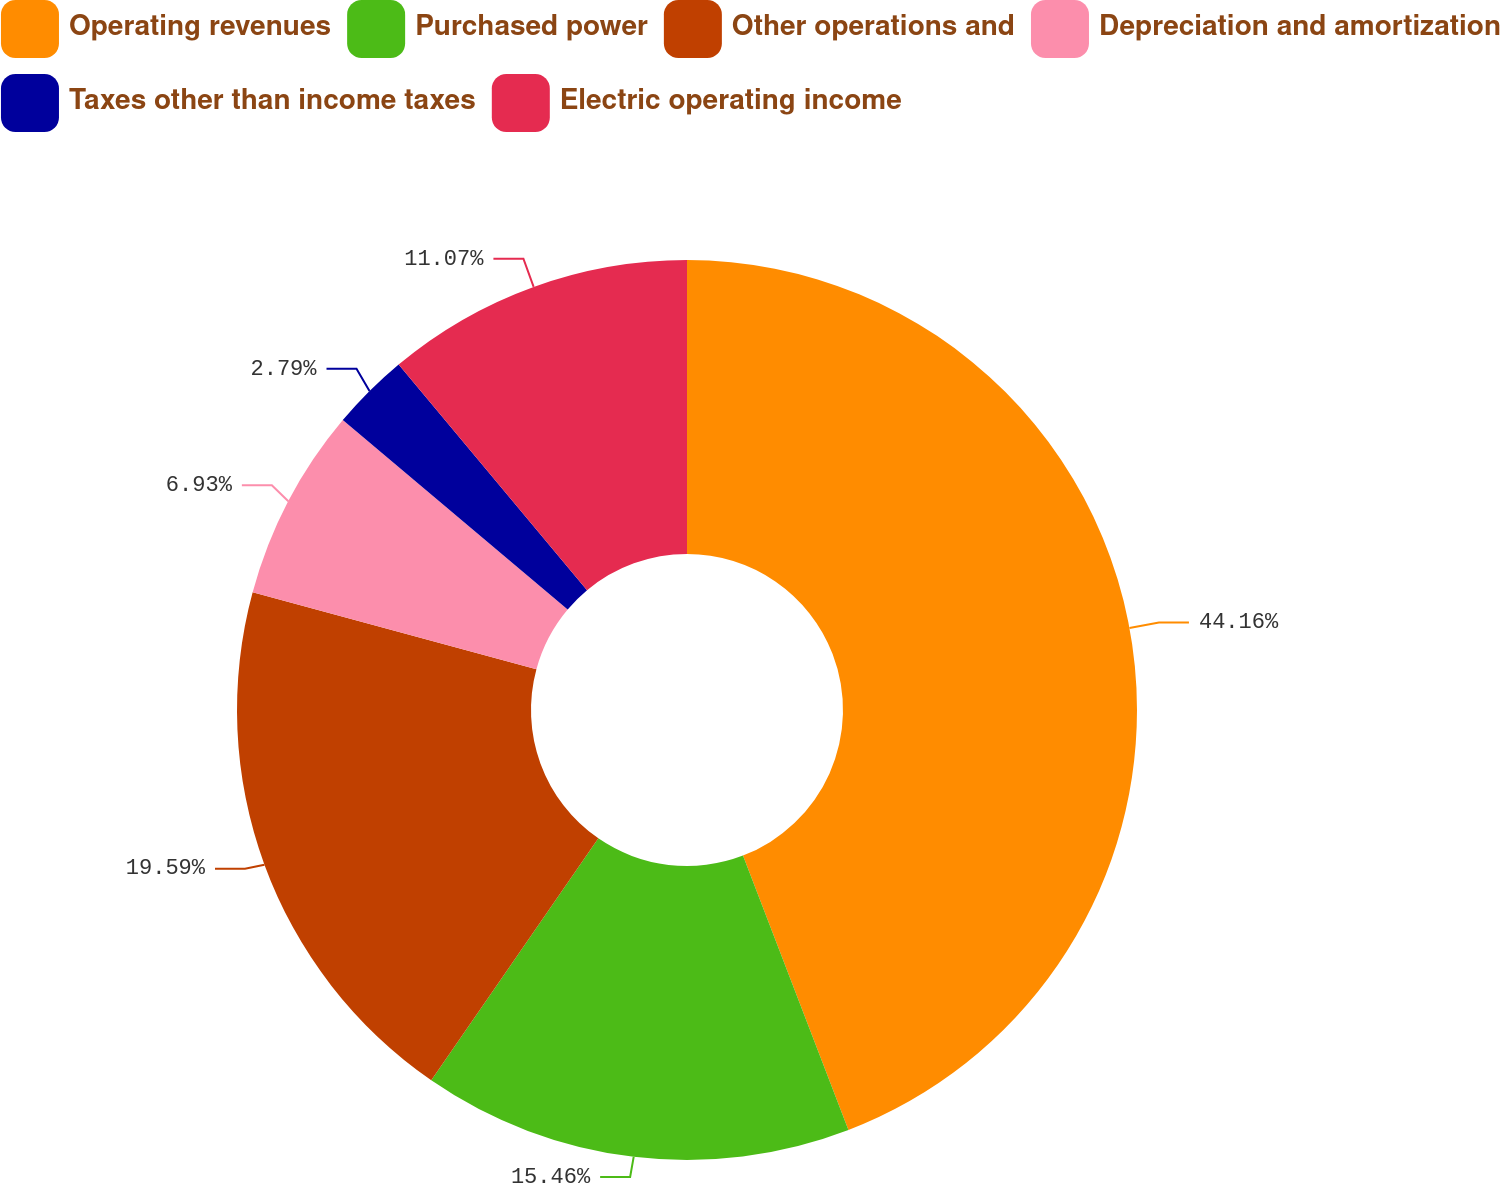Convert chart to OTSL. <chart><loc_0><loc_0><loc_500><loc_500><pie_chart><fcel>Operating revenues<fcel>Purchased power<fcel>Other operations and<fcel>Depreciation and amortization<fcel>Taxes other than income taxes<fcel>Electric operating income<nl><fcel>44.16%<fcel>15.46%<fcel>19.59%<fcel>6.93%<fcel>2.79%<fcel>11.07%<nl></chart> 